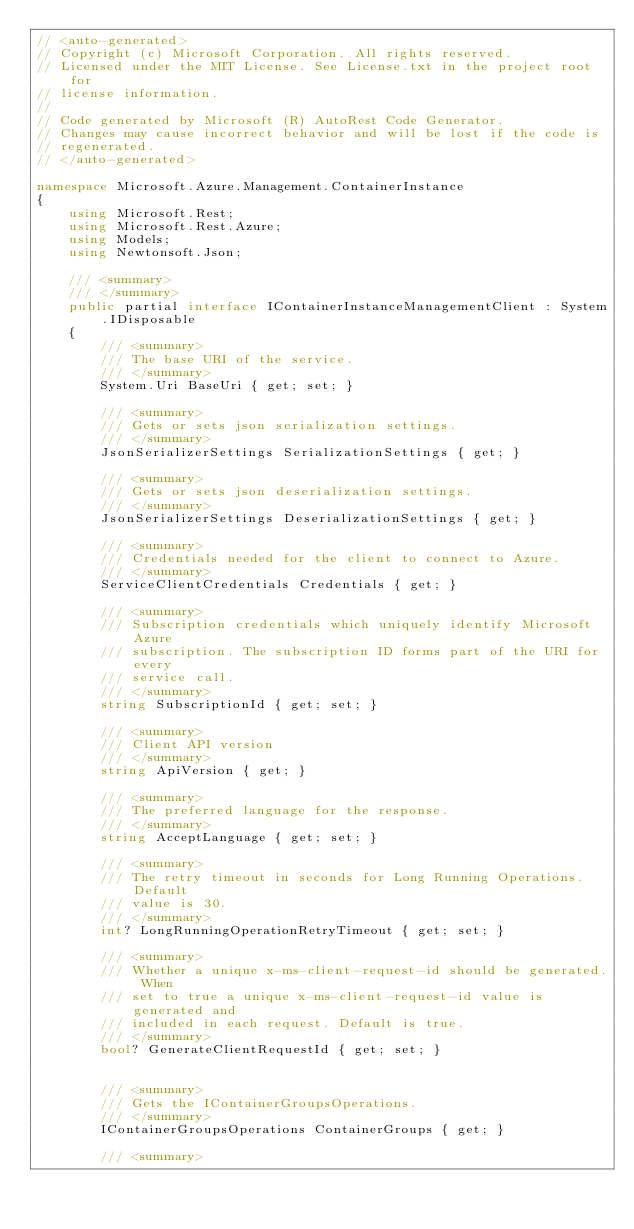Convert code to text. <code><loc_0><loc_0><loc_500><loc_500><_C#_>// <auto-generated>
// Copyright (c) Microsoft Corporation. All rights reserved.
// Licensed under the MIT License. See License.txt in the project root for
// license information.
//
// Code generated by Microsoft (R) AutoRest Code Generator.
// Changes may cause incorrect behavior and will be lost if the code is
// regenerated.
// </auto-generated>

namespace Microsoft.Azure.Management.ContainerInstance
{
    using Microsoft.Rest;
    using Microsoft.Rest.Azure;
    using Models;
    using Newtonsoft.Json;

    /// <summary>
    /// </summary>
    public partial interface IContainerInstanceManagementClient : System.IDisposable
    {
        /// <summary>
        /// The base URI of the service.
        /// </summary>
        System.Uri BaseUri { get; set; }

        /// <summary>
        /// Gets or sets json serialization settings.
        /// </summary>
        JsonSerializerSettings SerializationSettings { get; }

        /// <summary>
        /// Gets or sets json deserialization settings.
        /// </summary>
        JsonSerializerSettings DeserializationSettings { get; }

        /// <summary>
        /// Credentials needed for the client to connect to Azure.
        /// </summary>
        ServiceClientCredentials Credentials { get; }

        /// <summary>
        /// Subscription credentials which uniquely identify Microsoft Azure
        /// subscription. The subscription ID forms part of the URI for every
        /// service call.
        /// </summary>
        string SubscriptionId { get; set; }

        /// <summary>
        /// Client API version
        /// </summary>
        string ApiVersion { get; }

        /// <summary>
        /// The preferred language for the response.
        /// </summary>
        string AcceptLanguage { get; set; }

        /// <summary>
        /// The retry timeout in seconds for Long Running Operations. Default
        /// value is 30.
        /// </summary>
        int? LongRunningOperationRetryTimeout { get; set; }

        /// <summary>
        /// Whether a unique x-ms-client-request-id should be generated. When
        /// set to true a unique x-ms-client-request-id value is generated and
        /// included in each request. Default is true.
        /// </summary>
        bool? GenerateClientRequestId { get; set; }


        /// <summary>
        /// Gets the IContainerGroupsOperations.
        /// </summary>
        IContainerGroupsOperations ContainerGroups { get; }

        /// <summary></code> 